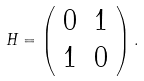Convert formula to latex. <formula><loc_0><loc_0><loc_500><loc_500>H = \left ( \begin{array} { c c } { 0 } & { 1 } \\ { 1 } & { 0 } \end{array} \right ) .</formula> 